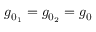<formula> <loc_0><loc_0><loc_500><loc_500>g _ { 0 _ { 1 } } = g _ { 0 _ { 2 } } = g _ { 0 }</formula> 